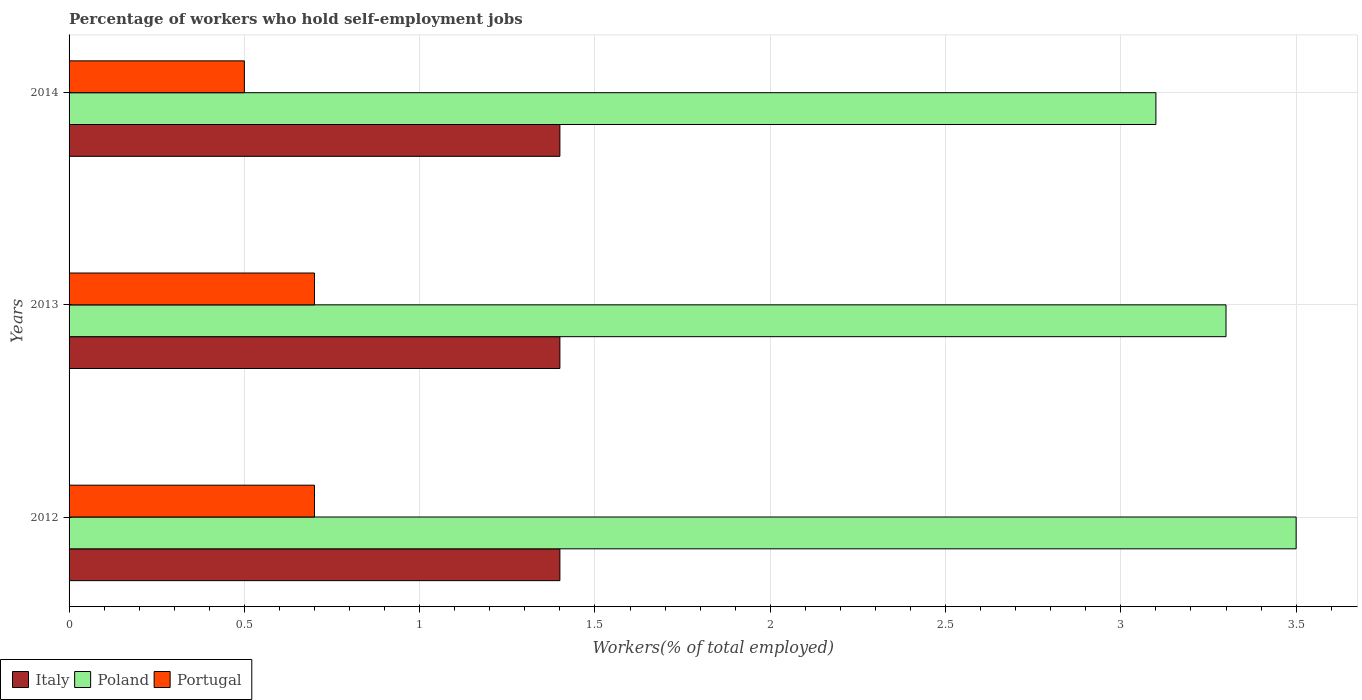How many different coloured bars are there?
Make the answer very short. 3. How many groups of bars are there?
Provide a succinct answer. 3. Are the number of bars per tick equal to the number of legend labels?
Give a very brief answer. Yes. What is the label of the 1st group of bars from the top?
Give a very brief answer. 2014. In how many cases, is the number of bars for a given year not equal to the number of legend labels?
Give a very brief answer. 0. What is the percentage of self-employed workers in Italy in 2014?
Your answer should be compact. 1.4. Across all years, what is the maximum percentage of self-employed workers in Portugal?
Your answer should be very brief. 0.7. Across all years, what is the minimum percentage of self-employed workers in Italy?
Give a very brief answer. 1.4. What is the total percentage of self-employed workers in Poland in the graph?
Your response must be concise. 9.9. What is the difference between the percentage of self-employed workers in Portugal in 2012 and that in 2014?
Provide a succinct answer. 0.2. What is the difference between the percentage of self-employed workers in Italy in 2013 and the percentage of self-employed workers in Portugal in 2012?
Make the answer very short. 0.7. What is the average percentage of self-employed workers in Portugal per year?
Provide a succinct answer. 0.63. In the year 2012, what is the difference between the percentage of self-employed workers in Portugal and percentage of self-employed workers in Italy?
Offer a terse response. -0.7. In how many years, is the percentage of self-employed workers in Portugal greater than 1.7 %?
Your answer should be very brief. 0. What is the ratio of the percentage of self-employed workers in Poland in 2012 to that in 2014?
Offer a terse response. 1.13. Is the percentage of self-employed workers in Poland in 2012 less than that in 2013?
Your answer should be compact. No. What is the difference between the highest and the second highest percentage of self-employed workers in Poland?
Your answer should be compact. 0.2. What is the difference between the highest and the lowest percentage of self-employed workers in Italy?
Your answer should be very brief. 0. In how many years, is the percentage of self-employed workers in Poland greater than the average percentage of self-employed workers in Poland taken over all years?
Your response must be concise. 1. Is the sum of the percentage of self-employed workers in Italy in 2012 and 2014 greater than the maximum percentage of self-employed workers in Portugal across all years?
Your answer should be compact. Yes. What does the 2nd bar from the top in 2012 represents?
Make the answer very short. Poland. Is it the case that in every year, the sum of the percentage of self-employed workers in Poland and percentage of self-employed workers in Portugal is greater than the percentage of self-employed workers in Italy?
Provide a succinct answer. Yes. How many bars are there?
Your answer should be compact. 9. Are all the bars in the graph horizontal?
Offer a very short reply. Yes. What is the difference between two consecutive major ticks on the X-axis?
Offer a terse response. 0.5. Are the values on the major ticks of X-axis written in scientific E-notation?
Provide a succinct answer. No. Does the graph contain grids?
Your response must be concise. Yes. How are the legend labels stacked?
Give a very brief answer. Horizontal. What is the title of the graph?
Give a very brief answer. Percentage of workers who hold self-employment jobs. Does "Armenia" appear as one of the legend labels in the graph?
Provide a succinct answer. No. What is the label or title of the X-axis?
Offer a very short reply. Workers(% of total employed). What is the Workers(% of total employed) of Italy in 2012?
Your response must be concise. 1.4. What is the Workers(% of total employed) of Poland in 2012?
Your answer should be very brief. 3.5. What is the Workers(% of total employed) of Portugal in 2012?
Give a very brief answer. 0.7. What is the Workers(% of total employed) in Italy in 2013?
Make the answer very short. 1.4. What is the Workers(% of total employed) in Poland in 2013?
Offer a terse response. 3.3. What is the Workers(% of total employed) of Portugal in 2013?
Offer a very short reply. 0.7. What is the Workers(% of total employed) of Italy in 2014?
Offer a terse response. 1.4. What is the Workers(% of total employed) in Poland in 2014?
Provide a short and direct response. 3.1. Across all years, what is the maximum Workers(% of total employed) of Italy?
Ensure brevity in your answer.  1.4. Across all years, what is the maximum Workers(% of total employed) in Poland?
Your answer should be compact. 3.5. Across all years, what is the maximum Workers(% of total employed) of Portugal?
Give a very brief answer. 0.7. Across all years, what is the minimum Workers(% of total employed) of Italy?
Ensure brevity in your answer.  1.4. Across all years, what is the minimum Workers(% of total employed) in Poland?
Your answer should be compact. 3.1. What is the total Workers(% of total employed) in Poland in the graph?
Ensure brevity in your answer.  9.9. What is the difference between the Workers(% of total employed) of Italy in 2012 and that in 2013?
Offer a terse response. 0. What is the difference between the Workers(% of total employed) of Portugal in 2012 and that in 2013?
Give a very brief answer. 0. What is the difference between the Workers(% of total employed) in Italy in 2012 and that in 2014?
Provide a short and direct response. 0. What is the difference between the Workers(% of total employed) of Portugal in 2012 and that in 2014?
Your response must be concise. 0.2. What is the difference between the Workers(% of total employed) of Italy in 2012 and the Workers(% of total employed) of Poland in 2013?
Keep it short and to the point. -1.9. What is the difference between the Workers(% of total employed) of Italy in 2012 and the Workers(% of total employed) of Portugal in 2013?
Provide a succinct answer. 0.7. What is the difference between the Workers(% of total employed) of Italy in 2012 and the Workers(% of total employed) of Poland in 2014?
Offer a terse response. -1.7. What is the difference between the Workers(% of total employed) in Italy in 2012 and the Workers(% of total employed) in Portugal in 2014?
Ensure brevity in your answer.  0.9. What is the difference between the Workers(% of total employed) of Poland in 2012 and the Workers(% of total employed) of Portugal in 2014?
Offer a terse response. 3. What is the difference between the Workers(% of total employed) in Italy in 2013 and the Workers(% of total employed) in Poland in 2014?
Your answer should be compact. -1.7. What is the difference between the Workers(% of total employed) of Poland in 2013 and the Workers(% of total employed) of Portugal in 2014?
Give a very brief answer. 2.8. What is the average Workers(% of total employed) of Poland per year?
Your answer should be compact. 3.3. What is the average Workers(% of total employed) in Portugal per year?
Your answer should be compact. 0.63. In the year 2012, what is the difference between the Workers(% of total employed) of Italy and Workers(% of total employed) of Poland?
Provide a short and direct response. -2.1. In the year 2013, what is the difference between the Workers(% of total employed) in Italy and Workers(% of total employed) in Portugal?
Ensure brevity in your answer.  0.7. In the year 2013, what is the difference between the Workers(% of total employed) in Poland and Workers(% of total employed) in Portugal?
Your answer should be compact. 2.6. In the year 2014, what is the difference between the Workers(% of total employed) in Italy and Workers(% of total employed) in Portugal?
Your answer should be compact. 0.9. In the year 2014, what is the difference between the Workers(% of total employed) in Poland and Workers(% of total employed) in Portugal?
Ensure brevity in your answer.  2.6. What is the ratio of the Workers(% of total employed) of Poland in 2012 to that in 2013?
Make the answer very short. 1.06. What is the ratio of the Workers(% of total employed) in Italy in 2012 to that in 2014?
Ensure brevity in your answer.  1. What is the ratio of the Workers(% of total employed) in Poland in 2012 to that in 2014?
Make the answer very short. 1.13. What is the ratio of the Workers(% of total employed) of Italy in 2013 to that in 2014?
Offer a terse response. 1. What is the ratio of the Workers(% of total employed) in Poland in 2013 to that in 2014?
Ensure brevity in your answer.  1.06. What is the ratio of the Workers(% of total employed) in Portugal in 2013 to that in 2014?
Your response must be concise. 1.4. What is the difference between the highest and the second highest Workers(% of total employed) in Italy?
Your answer should be very brief. 0. What is the difference between the highest and the second highest Workers(% of total employed) in Portugal?
Give a very brief answer. 0. What is the difference between the highest and the lowest Workers(% of total employed) in Poland?
Ensure brevity in your answer.  0.4. 